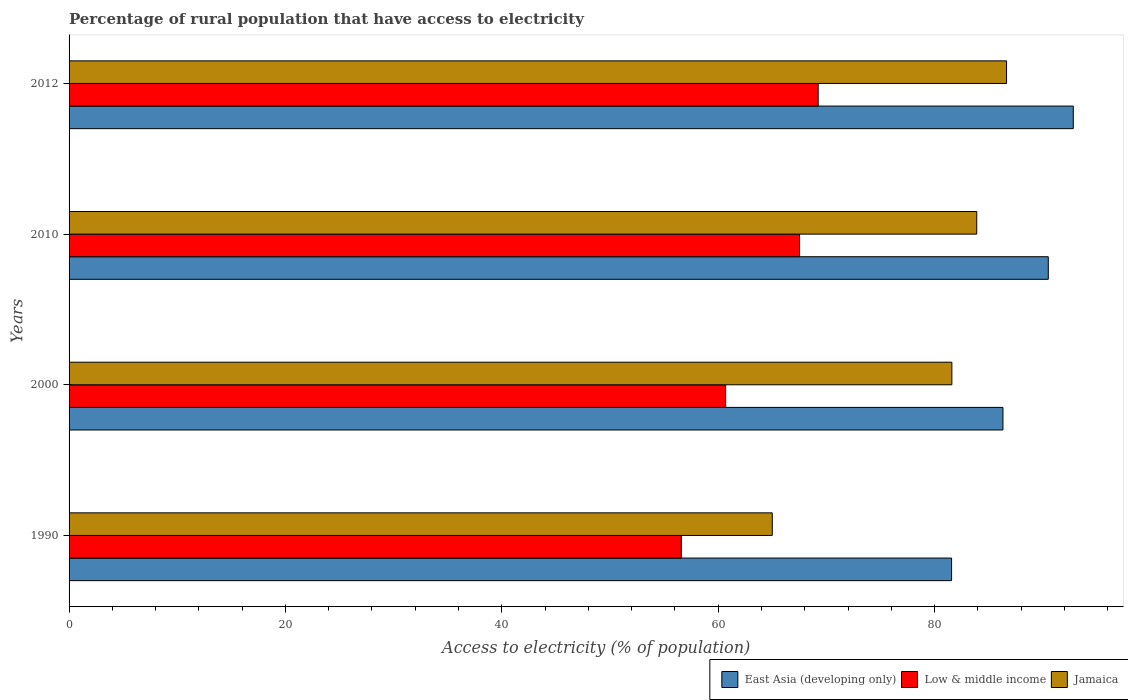Are the number of bars on each tick of the Y-axis equal?
Your answer should be compact. Yes. How many bars are there on the 3rd tick from the top?
Make the answer very short. 3. What is the percentage of rural population that have access to electricity in Jamaica in 2012?
Give a very brief answer. 86.65. Across all years, what is the maximum percentage of rural population that have access to electricity in East Asia (developing only)?
Provide a succinct answer. 92.82. Across all years, what is the minimum percentage of rural population that have access to electricity in East Asia (developing only)?
Offer a terse response. 81.57. In which year was the percentage of rural population that have access to electricity in Jamaica minimum?
Offer a very short reply. 1990. What is the total percentage of rural population that have access to electricity in East Asia (developing only) in the graph?
Provide a succinct answer. 351.23. What is the difference between the percentage of rural population that have access to electricity in East Asia (developing only) in 1990 and that in 2010?
Ensure brevity in your answer.  -8.94. What is the difference between the percentage of rural population that have access to electricity in East Asia (developing only) in 2010 and the percentage of rural population that have access to electricity in Jamaica in 2000?
Offer a very short reply. 8.91. What is the average percentage of rural population that have access to electricity in Jamaica per year?
Provide a succinct answer. 79.29. In the year 2010, what is the difference between the percentage of rural population that have access to electricity in Low & middle income and percentage of rural population that have access to electricity in East Asia (developing only)?
Your answer should be compact. -22.99. In how many years, is the percentage of rural population that have access to electricity in Low & middle income greater than 44 %?
Provide a succinct answer. 4. What is the ratio of the percentage of rural population that have access to electricity in Jamaica in 2000 to that in 2012?
Provide a succinct answer. 0.94. Is the difference between the percentage of rural population that have access to electricity in Low & middle income in 1990 and 2010 greater than the difference between the percentage of rural population that have access to electricity in East Asia (developing only) in 1990 and 2010?
Keep it short and to the point. No. What is the difference between the highest and the second highest percentage of rural population that have access to electricity in East Asia (developing only)?
Make the answer very short. 2.31. What is the difference between the highest and the lowest percentage of rural population that have access to electricity in Low & middle income?
Offer a terse response. 12.65. What does the 3rd bar from the top in 2012 represents?
Provide a short and direct response. East Asia (developing only). What does the 2nd bar from the bottom in 2000 represents?
Make the answer very short. Low & middle income. Is it the case that in every year, the sum of the percentage of rural population that have access to electricity in Jamaica and percentage of rural population that have access to electricity in Low & middle income is greater than the percentage of rural population that have access to electricity in East Asia (developing only)?
Provide a succinct answer. Yes. Are all the bars in the graph horizontal?
Ensure brevity in your answer.  Yes. How many years are there in the graph?
Offer a terse response. 4. What is the difference between two consecutive major ticks on the X-axis?
Your response must be concise. 20. Are the values on the major ticks of X-axis written in scientific E-notation?
Offer a terse response. No. Does the graph contain any zero values?
Provide a short and direct response. No. Where does the legend appear in the graph?
Your response must be concise. Bottom right. What is the title of the graph?
Offer a terse response. Percentage of rural population that have access to electricity. Does "Germany" appear as one of the legend labels in the graph?
Your answer should be very brief. No. What is the label or title of the X-axis?
Make the answer very short. Access to electricity (% of population). What is the label or title of the Y-axis?
Offer a terse response. Years. What is the Access to electricity (% of population) of East Asia (developing only) in 1990?
Ensure brevity in your answer.  81.57. What is the Access to electricity (% of population) in Low & middle income in 1990?
Make the answer very short. 56.59. What is the Access to electricity (% of population) in East Asia (developing only) in 2000?
Give a very brief answer. 86.32. What is the Access to electricity (% of population) in Low & middle income in 2000?
Make the answer very short. 60.69. What is the Access to electricity (% of population) in Jamaica in 2000?
Offer a terse response. 81.6. What is the Access to electricity (% of population) of East Asia (developing only) in 2010?
Give a very brief answer. 90.51. What is the Access to electricity (% of population) in Low & middle income in 2010?
Offer a terse response. 67.52. What is the Access to electricity (% of population) in Jamaica in 2010?
Your answer should be compact. 83.9. What is the Access to electricity (% of population) of East Asia (developing only) in 2012?
Ensure brevity in your answer.  92.82. What is the Access to electricity (% of population) of Low & middle income in 2012?
Your answer should be very brief. 69.24. What is the Access to electricity (% of population) of Jamaica in 2012?
Give a very brief answer. 86.65. Across all years, what is the maximum Access to electricity (% of population) in East Asia (developing only)?
Keep it short and to the point. 92.82. Across all years, what is the maximum Access to electricity (% of population) of Low & middle income?
Provide a succinct answer. 69.24. Across all years, what is the maximum Access to electricity (% of population) in Jamaica?
Offer a very short reply. 86.65. Across all years, what is the minimum Access to electricity (% of population) in East Asia (developing only)?
Your answer should be very brief. 81.57. Across all years, what is the minimum Access to electricity (% of population) in Low & middle income?
Provide a succinct answer. 56.59. What is the total Access to electricity (% of population) of East Asia (developing only) in the graph?
Your answer should be very brief. 351.23. What is the total Access to electricity (% of population) in Low & middle income in the graph?
Your response must be concise. 254.04. What is the total Access to electricity (% of population) of Jamaica in the graph?
Your answer should be very brief. 317.15. What is the difference between the Access to electricity (% of population) of East Asia (developing only) in 1990 and that in 2000?
Offer a very short reply. -4.75. What is the difference between the Access to electricity (% of population) in Low & middle income in 1990 and that in 2000?
Make the answer very short. -4.1. What is the difference between the Access to electricity (% of population) in Jamaica in 1990 and that in 2000?
Offer a very short reply. -16.6. What is the difference between the Access to electricity (% of population) of East Asia (developing only) in 1990 and that in 2010?
Make the answer very short. -8.94. What is the difference between the Access to electricity (% of population) in Low & middle income in 1990 and that in 2010?
Your answer should be very brief. -10.93. What is the difference between the Access to electricity (% of population) in Jamaica in 1990 and that in 2010?
Your answer should be very brief. -18.9. What is the difference between the Access to electricity (% of population) in East Asia (developing only) in 1990 and that in 2012?
Provide a succinct answer. -11.25. What is the difference between the Access to electricity (% of population) of Low & middle income in 1990 and that in 2012?
Your response must be concise. -12.65. What is the difference between the Access to electricity (% of population) in Jamaica in 1990 and that in 2012?
Ensure brevity in your answer.  -21.65. What is the difference between the Access to electricity (% of population) of East Asia (developing only) in 2000 and that in 2010?
Ensure brevity in your answer.  -4.19. What is the difference between the Access to electricity (% of population) in Low & middle income in 2000 and that in 2010?
Offer a very short reply. -6.83. What is the difference between the Access to electricity (% of population) of East Asia (developing only) in 2000 and that in 2012?
Make the answer very short. -6.5. What is the difference between the Access to electricity (% of population) in Low & middle income in 2000 and that in 2012?
Provide a succinct answer. -8.55. What is the difference between the Access to electricity (% of population) in Jamaica in 2000 and that in 2012?
Provide a succinct answer. -5.05. What is the difference between the Access to electricity (% of population) of East Asia (developing only) in 2010 and that in 2012?
Offer a very short reply. -2.31. What is the difference between the Access to electricity (% of population) in Low & middle income in 2010 and that in 2012?
Offer a terse response. -1.72. What is the difference between the Access to electricity (% of population) of Jamaica in 2010 and that in 2012?
Make the answer very short. -2.75. What is the difference between the Access to electricity (% of population) in East Asia (developing only) in 1990 and the Access to electricity (% of population) in Low & middle income in 2000?
Your answer should be compact. 20.89. What is the difference between the Access to electricity (% of population) of East Asia (developing only) in 1990 and the Access to electricity (% of population) of Jamaica in 2000?
Keep it short and to the point. -0.03. What is the difference between the Access to electricity (% of population) in Low & middle income in 1990 and the Access to electricity (% of population) in Jamaica in 2000?
Provide a short and direct response. -25.01. What is the difference between the Access to electricity (% of population) of East Asia (developing only) in 1990 and the Access to electricity (% of population) of Low & middle income in 2010?
Provide a succinct answer. 14.05. What is the difference between the Access to electricity (% of population) of East Asia (developing only) in 1990 and the Access to electricity (% of population) of Jamaica in 2010?
Provide a short and direct response. -2.33. What is the difference between the Access to electricity (% of population) of Low & middle income in 1990 and the Access to electricity (% of population) of Jamaica in 2010?
Make the answer very short. -27.31. What is the difference between the Access to electricity (% of population) in East Asia (developing only) in 1990 and the Access to electricity (% of population) in Low & middle income in 2012?
Provide a succinct answer. 12.33. What is the difference between the Access to electricity (% of population) of East Asia (developing only) in 1990 and the Access to electricity (% of population) of Jamaica in 2012?
Keep it short and to the point. -5.08. What is the difference between the Access to electricity (% of population) in Low & middle income in 1990 and the Access to electricity (% of population) in Jamaica in 2012?
Your response must be concise. -30.06. What is the difference between the Access to electricity (% of population) in East Asia (developing only) in 2000 and the Access to electricity (% of population) in Low & middle income in 2010?
Give a very brief answer. 18.8. What is the difference between the Access to electricity (% of population) of East Asia (developing only) in 2000 and the Access to electricity (% of population) of Jamaica in 2010?
Offer a very short reply. 2.42. What is the difference between the Access to electricity (% of population) of Low & middle income in 2000 and the Access to electricity (% of population) of Jamaica in 2010?
Provide a succinct answer. -23.21. What is the difference between the Access to electricity (% of population) of East Asia (developing only) in 2000 and the Access to electricity (% of population) of Low & middle income in 2012?
Your answer should be very brief. 17.08. What is the difference between the Access to electricity (% of population) of East Asia (developing only) in 2000 and the Access to electricity (% of population) of Jamaica in 2012?
Give a very brief answer. -0.33. What is the difference between the Access to electricity (% of population) of Low & middle income in 2000 and the Access to electricity (% of population) of Jamaica in 2012?
Provide a short and direct response. -25.97. What is the difference between the Access to electricity (% of population) of East Asia (developing only) in 2010 and the Access to electricity (% of population) of Low & middle income in 2012?
Offer a terse response. 21.27. What is the difference between the Access to electricity (% of population) in East Asia (developing only) in 2010 and the Access to electricity (% of population) in Jamaica in 2012?
Offer a terse response. 3.86. What is the difference between the Access to electricity (% of population) of Low & middle income in 2010 and the Access to electricity (% of population) of Jamaica in 2012?
Make the answer very short. -19.13. What is the average Access to electricity (% of population) in East Asia (developing only) per year?
Make the answer very short. 87.81. What is the average Access to electricity (% of population) of Low & middle income per year?
Give a very brief answer. 63.51. What is the average Access to electricity (% of population) in Jamaica per year?
Your answer should be very brief. 79.29. In the year 1990, what is the difference between the Access to electricity (% of population) of East Asia (developing only) and Access to electricity (% of population) of Low & middle income?
Provide a short and direct response. 24.98. In the year 1990, what is the difference between the Access to electricity (% of population) of East Asia (developing only) and Access to electricity (% of population) of Jamaica?
Ensure brevity in your answer.  16.57. In the year 1990, what is the difference between the Access to electricity (% of population) in Low & middle income and Access to electricity (% of population) in Jamaica?
Your answer should be compact. -8.41. In the year 2000, what is the difference between the Access to electricity (% of population) in East Asia (developing only) and Access to electricity (% of population) in Low & middle income?
Make the answer very short. 25.63. In the year 2000, what is the difference between the Access to electricity (% of population) of East Asia (developing only) and Access to electricity (% of population) of Jamaica?
Provide a succinct answer. 4.72. In the year 2000, what is the difference between the Access to electricity (% of population) of Low & middle income and Access to electricity (% of population) of Jamaica?
Make the answer very short. -20.91. In the year 2010, what is the difference between the Access to electricity (% of population) in East Asia (developing only) and Access to electricity (% of population) in Low & middle income?
Give a very brief answer. 22.99. In the year 2010, what is the difference between the Access to electricity (% of population) of East Asia (developing only) and Access to electricity (% of population) of Jamaica?
Make the answer very short. 6.61. In the year 2010, what is the difference between the Access to electricity (% of population) in Low & middle income and Access to electricity (% of population) in Jamaica?
Provide a succinct answer. -16.38. In the year 2012, what is the difference between the Access to electricity (% of population) in East Asia (developing only) and Access to electricity (% of population) in Low & middle income?
Provide a succinct answer. 23.58. In the year 2012, what is the difference between the Access to electricity (% of population) in East Asia (developing only) and Access to electricity (% of population) in Jamaica?
Offer a very short reply. 6.17. In the year 2012, what is the difference between the Access to electricity (% of population) in Low & middle income and Access to electricity (% of population) in Jamaica?
Your answer should be very brief. -17.41. What is the ratio of the Access to electricity (% of population) of East Asia (developing only) in 1990 to that in 2000?
Offer a very short reply. 0.94. What is the ratio of the Access to electricity (% of population) in Low & middle income in 1990 to that in 2000?
Make the answer very short. 0.93. What is the ratio of the Access to electricity (% of population) in Jamaica in 1990 to that in 2000?
Make the answer very short. 0.8. What is the ratio of the Access to electricity (% of population) in East Asia (developing only) in 1990 to that in 2010?
Offer a very short reply. 0.9. What is the ratio of the Access to electricity (% of population) in Low & middle income in 1990 to that in 2010?
Offer a terse response. 0.84. What is the ratio of the Access to electricity (% of population) in Jamaica in 1990 to that in 2010?
Provide a succinct answer. 0.77. What is the ratio of the Access to electricity (% of population) in East Asia (developing only) in 1990 to that in 2012?
Offer a terse response. 0.88. What is the ratio of the Access to electricity (% of population) of Low & middle income in 1990 to that in 2012?
Offer a terse response. 0.82. What is the ratio of the Access to electricity (% of population) in Jamaica in 1990 to that in 2012?
Your answer should be compact. 0.75. What is the ratio of the Access to electricity (% of population) of East Asia (developing only) in 2000 to that in 2010?
Give a very brief answer. 0.95. What is the ratio of the Access to electricity (% of population) in Low & middle income in 2000 to that in 2010?
Your response must be concise. 0.9. What is the ratio of the Access to electricity (% of population) of Jamaica in 2000 to that in 2010?
Make the answer very short. 0.97. What is the ratio of the Access to electricity (% of population) of Low & middle income in 2000 to that in 2012?
Make the answer very short. 0.88. What is the ratio of the Access to electricity (% of population) in Jamaica in 2000 to that in 2012?
Ensure brevity in your answer.  0.94. What is the ratio of the Access to electricity (% of population) of East Asia (developing only) in 2010 to that in 2012?
Offer a terse response. 0.98. What is the ratio of the Access to electricity (% of population) in Low & middle income in 2010 to that in 2012?
Provide a short and direct response. 0.98. What is the ratio of the Access to electricity (% of population) in Jamaica in 2010 to that in 2012?
Provide a short and direct response. 0.97. What is the difference between the highest and the second highest Access to electricity (% of population) in East Asia (developing only)?
Give a very brief answer. 2.31. What is the difference between the highest and the second highest Access to electricity (% of population) in Low & middle income?
Make the answer very short. 1.72. What is the difference between the highest and the second highest Access to electricity (% of population) in Jamaica?
Give a very brief answer. 2.75. What is the difference between the highest and the lowest Access to electricity (% of population) of East Asia (developing only)?
Offer a very short reply. 11.25. What is the difference between the highest and the lowest Access to electricity (% of population) in Low & middle income?
Provide a succinct answer. 12.65. What is the difference between the highest and the lowest Access to electricity (% of population) of Jamaica?
Provide a short and direct response. 21.65. 